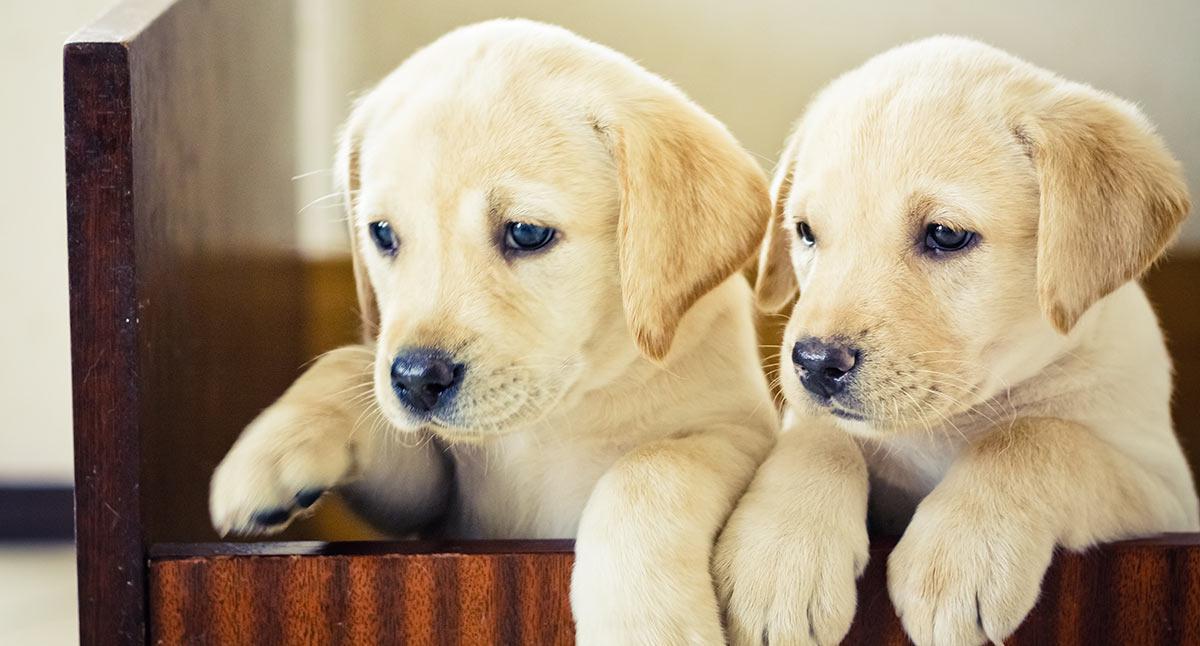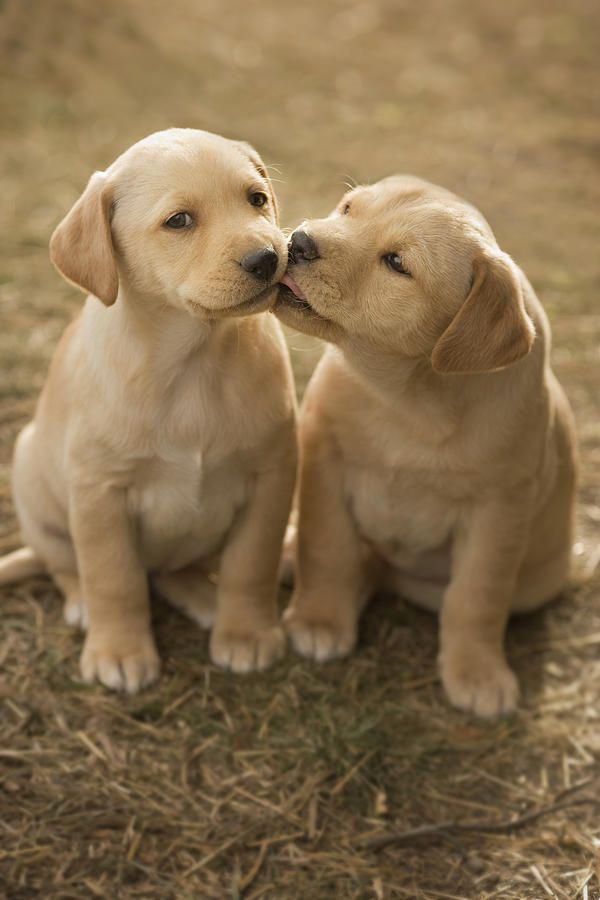The first image is the image on the left, the second image is the image on the right. For the images displayed, is the sentence "There are 4 puppies." factually correct? Answer yes or no. Yes. The first image is the image on the left, the second image is the image on the right. For the images shown, is this caption "All dogs are puppies with light-colored fur, and each image features a pair of puppies posed close together." true? Answer yes or no. Yes. 